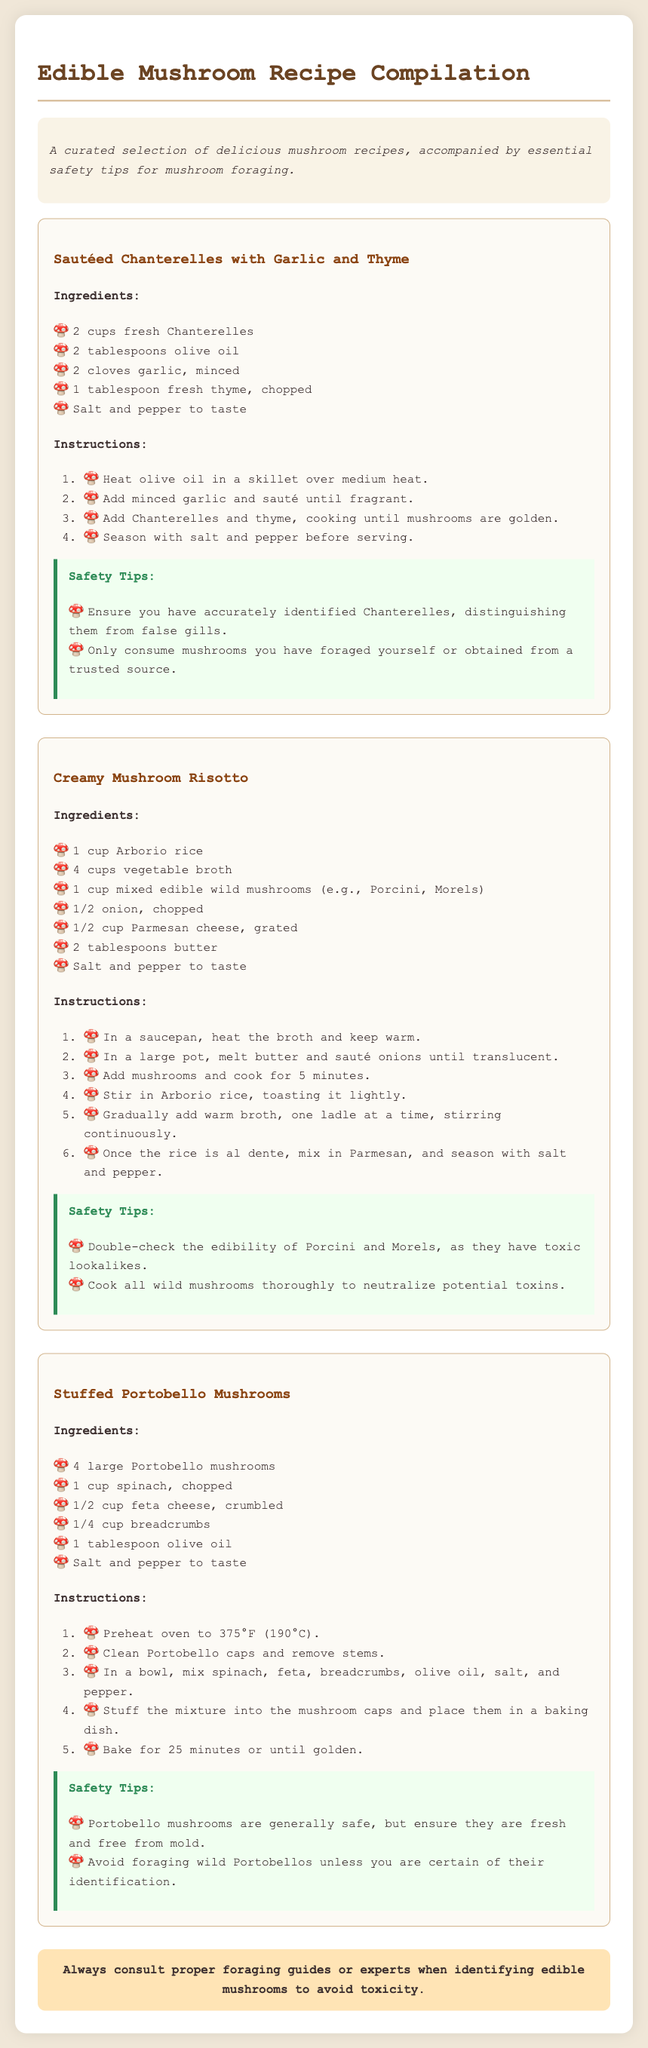What is the title of the document? The title is specified in the head section of the HTML document.
Answer: Edible Mushroom Recipe Compilation How many cups of fresh Chanterelles are needed? The amount of Chanterelles is listed in the ingredients section for the Sautéed Chanterelles recipe.
Answer: 2 cups What is a key safety tip for Chanterelles? The safety tips for each recipe highlight important precautions for mushroom foraging.
Answer: Ensure you have accurately identified Chanterelles, distinguishing them from false gills What type of rice is used in the Creamy Mushroom Risotto? The type of rice is mentioned in the ingredients used for the risotto recipe.
Answer: Arborio rice Which mushrooms are recommended for the Stuffed Portobello Mushrooms recipe? The ingredients list specifically mentions the type of mushrooms used in the recipe.
Answer: Portobello mushrooms What should you do to neutralize potential toxins in wild mushrooms? This information is found in the safety tips associated with the Creamy Mushroom Risotto recipe.
Answer: Cook all wild mushrooms thoroughly How long should the Portobello mushrooms be baked? The baking time is detailed in the instructions for the Stuffed Portobello Mushrooms recipe.
Answer: 25 minutes What is included in the introduction section of the document? The introduction provides an overview of what the document contains, stated just after the title.
Answer: A curated selection of delicious mushroom recipes, accompanied by essential safety tips for mushroom foraging 